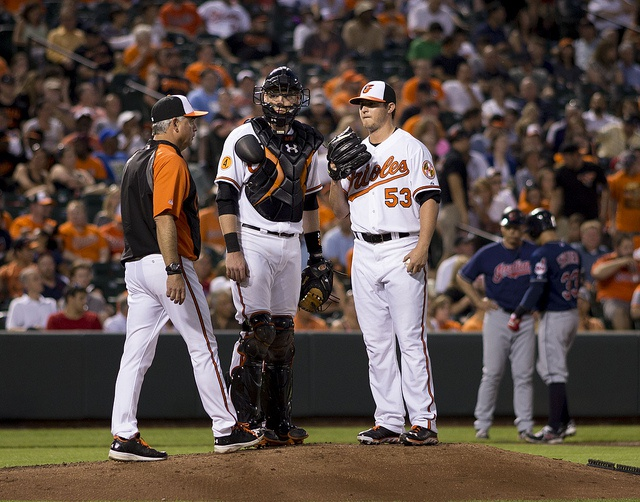Describe the objects in this image and their specific colors. I can see people in maroon, black, and gray tones, people in maroon, black, darkgray, lavender, and gray tones, people in maroon, lavender, black, darkgray, and gray tones, people in maroon, black, lavender, and darkgray tones, and people in maroon, black, and gray tones in this image. 